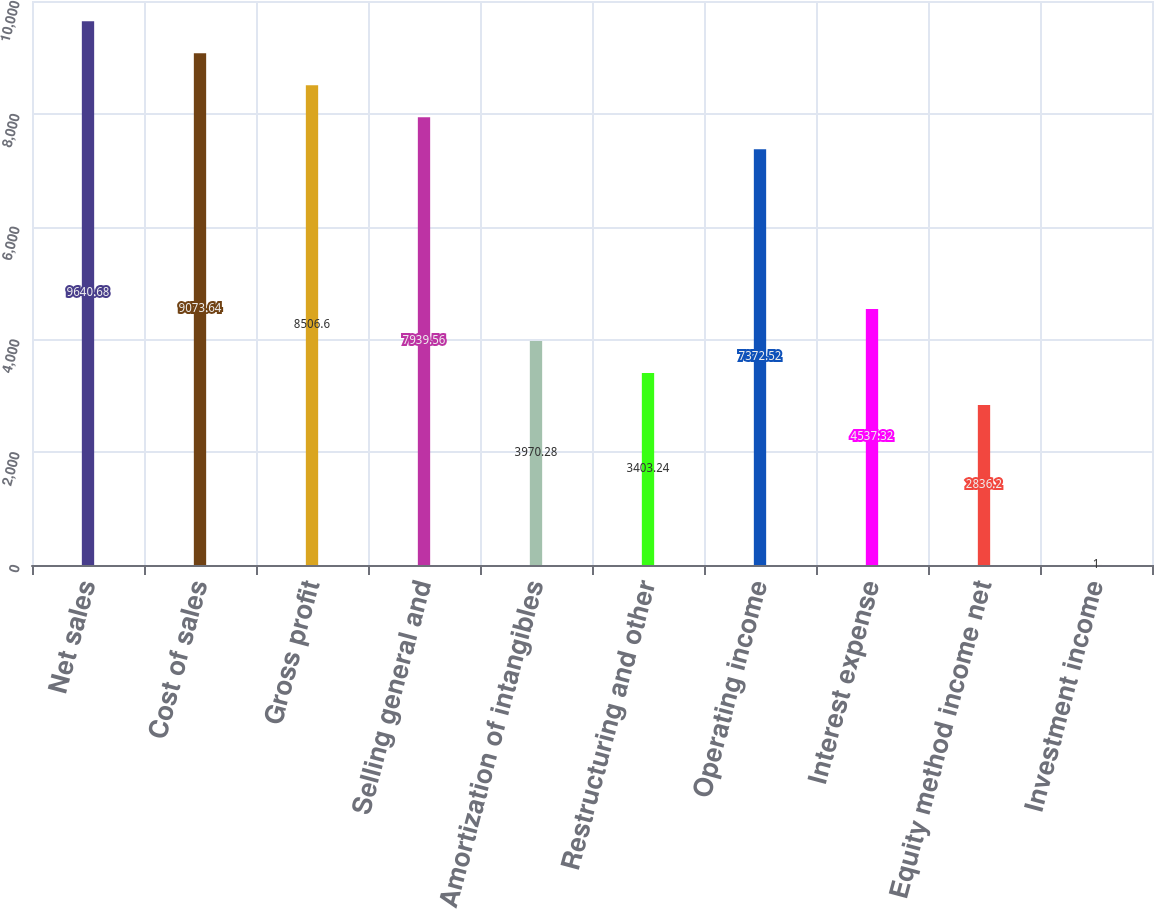<chart> <loc_0><loc_0><loc_500><loc_500><bar_chart><fcel>Net sales<fcel>Cost of sales<fcel>Gross profit<fcel>Selling general and<fcel>Amortization of intangibles<fcel>Restructuring and other<fcel>Operating income<fcel>Interest expense<fcel>Equity method income net<fcel>Investment income<nl><fcel>9640.68<fcel>9073.64<fcel>8506.6<fcel>7939.56<fcel>3970.28<fcel>3403.24<fcel>7372.52<fcel>4537.32<fcel>2836.2<fcel>1<nl></chart> 